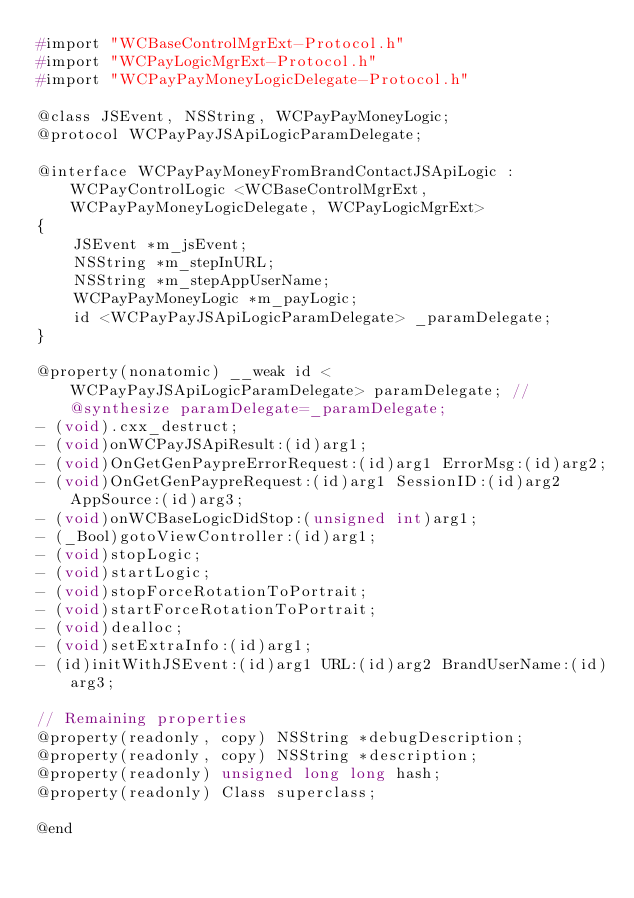<code> <loc_0><loc_0><loc_500><loc_500><_C_>#import "WCBaseControlMgrExt-Protocol.h"
#import "WCPayLogicMgrExt-Protocol.h"
#import "WCPayPayMoneyLogicDelegate-Protocol.h"

@class JSEvent, NSString, WCPayPayMoneyLogic;
@protocol WCPayPayJSApiLogicParamDelegate;

@interface WCPayPayMoneyFromBrandContactJSApiLogic : WCPayControlLogic <WCBaseControlMgrExt, WCPayPayMoneyLogicDelegate, WCPayLogicMgrExt>
{
    JSEvent *m_jsEvent;
    NSString *m_stepInURL;
    NSString *m_stepAppUserName;
    WCPayPayMoneyLogic *m_payLogic;
    id <WCPayPayJSApiLogicParamDelegate> _paramDelegate;
}

@property(nonatomic) __weak id <WCPayPayJSApiLogicParamDelegate> paramDelegate; // @synthesize paramDelegate=_paramDelegate;
- (void).cxx_destruct;
- (void)onWCPayJSApiResult:(id)arg1;
- (void)OnGetGenPaypreErrorRequest:(id)arg1 ErrorMsg:(id)arg2;
- (void)OnGetGenPaypreRequest:(id)arg1 SessionID:(id)arg2 AppSource:(id)arg3;
- (void)onWCBaseLogicDidStop:(unsigned int)arg1;
- (_Bool)gotoViewController:(id)arg1;
- (void)stopLogic;
- (void)startLogic;
- (void)stopForceRotationToPortrait;
- (void)startForceRotationToPortrait;
- (void)dealloc;
- (void)setExtraInfo:(id)arg1;
- (id)initWithJSEvent:(id)arg1 URL:(id)arg2 BrandUserName:(id)arg3;

// Remaining properties
@property(readonly, copy) NSString *debugDescription;
@property(readonly, copy) NSString *description;
@property(readonly) unsigned long long hash;
@property(readonly) Class superclass;

@end

</code> 